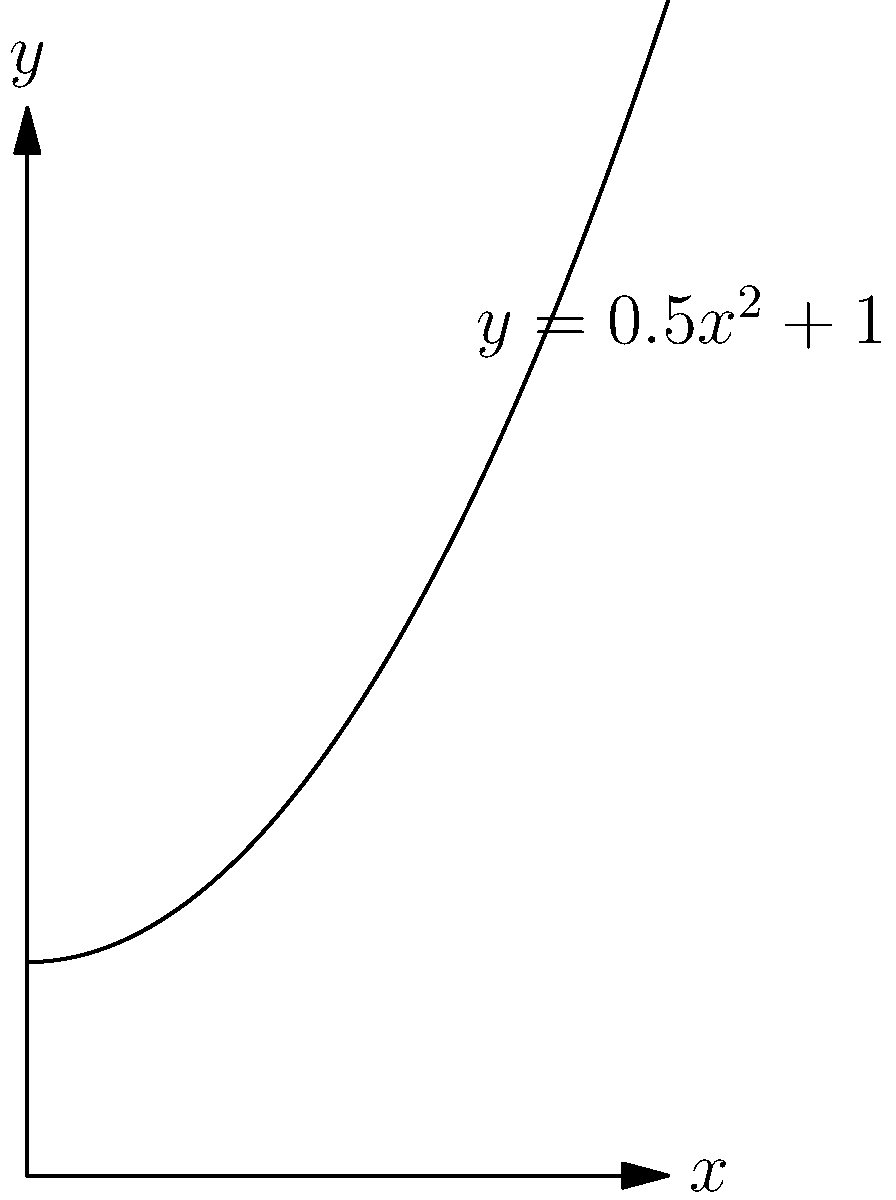As you sharpen your prized chef's knife, you notice its curved blade resembles a parabola. The curve of the blade can be represented by the function $y = 0.5x^2 + 1$ from $x = 0$ to $x = 3$ (in centimeters). Calculate the arc length of the blade using the arc length formula:

$$ L = \int_a^b \sqrt{1 + \left(\frac{dy}{dx}\right)^2} dx $$

Round your answer to two decimal places. Let's approach this step-by-step:

1) First, we need to find $\frac{dy}{dx}$:
   $y = 0.5x^2 + 1$
   $\frac{dy}{dx} = x$

2) Now, let's substitute this into the arc length formula:
   $L = \int_0^3 \sqrt{1 + (x)^2} dx$

3) Simplify under the square root:
   $L = \int_0^3 \sqrt{1 + x^2} dx$

4) This integral doesn't have an elementary antiderivative. We need to use the hyperbolic sine function:
   $\int \sqrt{1+x^2} dx = \frac{x}{2}\sqrt{1+x^2} + \frac{1}{2}\ln(x+\sqrt{1+x^2}) + C$

5) Now, let's evaluate this from 0 to 3:
   $L = [\frac{x}{2}\sqrt{1+x^2} + \frac{1}{2}\ln(x+\sqrt{1+x^2})]_0^3$

6) Substitute the limits:
   $L = [\frac{3}{2}\sqrt{1+3^2} + \frac{1}{2}\ln(3+\sqrt{1+3^2})] - [0 + \frac{1}{2}\ln(0+1)]$

7) Simplify:
   $L = \frac{3}{2}\sqrt{10} + \frac{1}{2}\ln(3+\sqrt{10}) - 0$

8) Calculate and round to two decimal places:
   $L \approx 4.74 + 1.15 = 5.89$ cm
Answer: 5.89 cm 